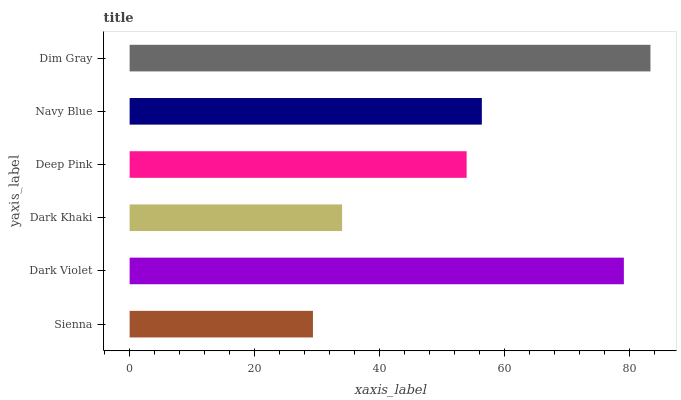Is Sienna the minimum?
Answer yes or no. Yes. Is Dim Gray the maximum?
Answer yes or no. Yes. Is Dark Violet the minimum?
Answer yes or no. No. Is Dark Violet the maximum?
Answer yes or no. No. Is Dark Violet greater than Sienna?
Answer yes or no. Yes. Is Sienna less than Dark Violet?
Answer yes or no. Yes. Is Sienna greater than Dark Violet?
Answer yes or no. No. Is Dark Violet less than Sienna?
Answer yes or no. No. Is Navy Blue the high median?
Answer yes or no. Yes. Is Deep Pink the low median?
Answer yes or no. Yes. Is Deep Pink the high median?
Answer yes or no. No. Is Dark Khaki the low median?
Answer yes or no. No. 